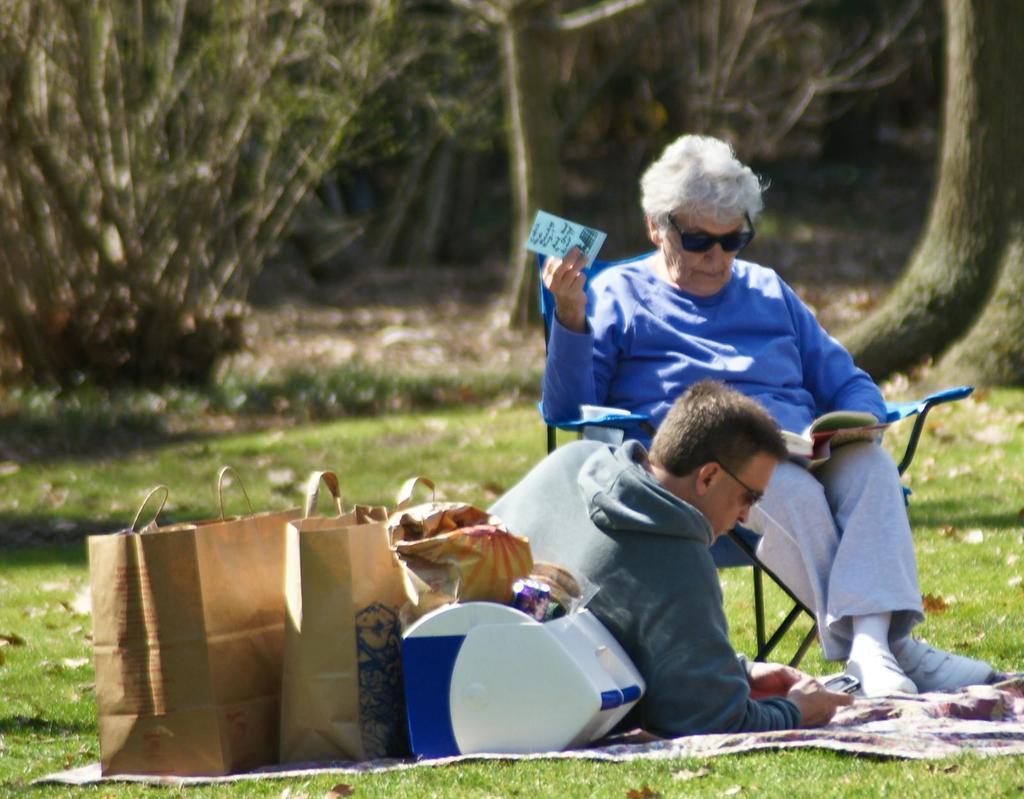Describe this image in one or two sentences. In this image, we can see a person sitting on a chair and holding a card. A man holding a mobile on the mat. On the mat we can see carry bags and box. At the bottom, there is a grass. In the background, we can see the blur view, plants and trees. 